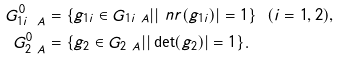Convert formula to latex. <formula><loc_0><loc_0><loc_500><loc_500>G _ { 1 i \ A } ^ { 0 } & = \{ g _ { 1 i } \in G _ { 1 i \ A } | | \ n r ( g _ { 1 i } ) | = 1 \} \ \ ( i = 1 , 2 ) , \\ G _ { 2 \ A } ^ { 0 } & = \{ g _ { 2 } \in G _ { 2 \ A } | | \det ( g _ { 2 } ) | = 1 \} .</formula> 